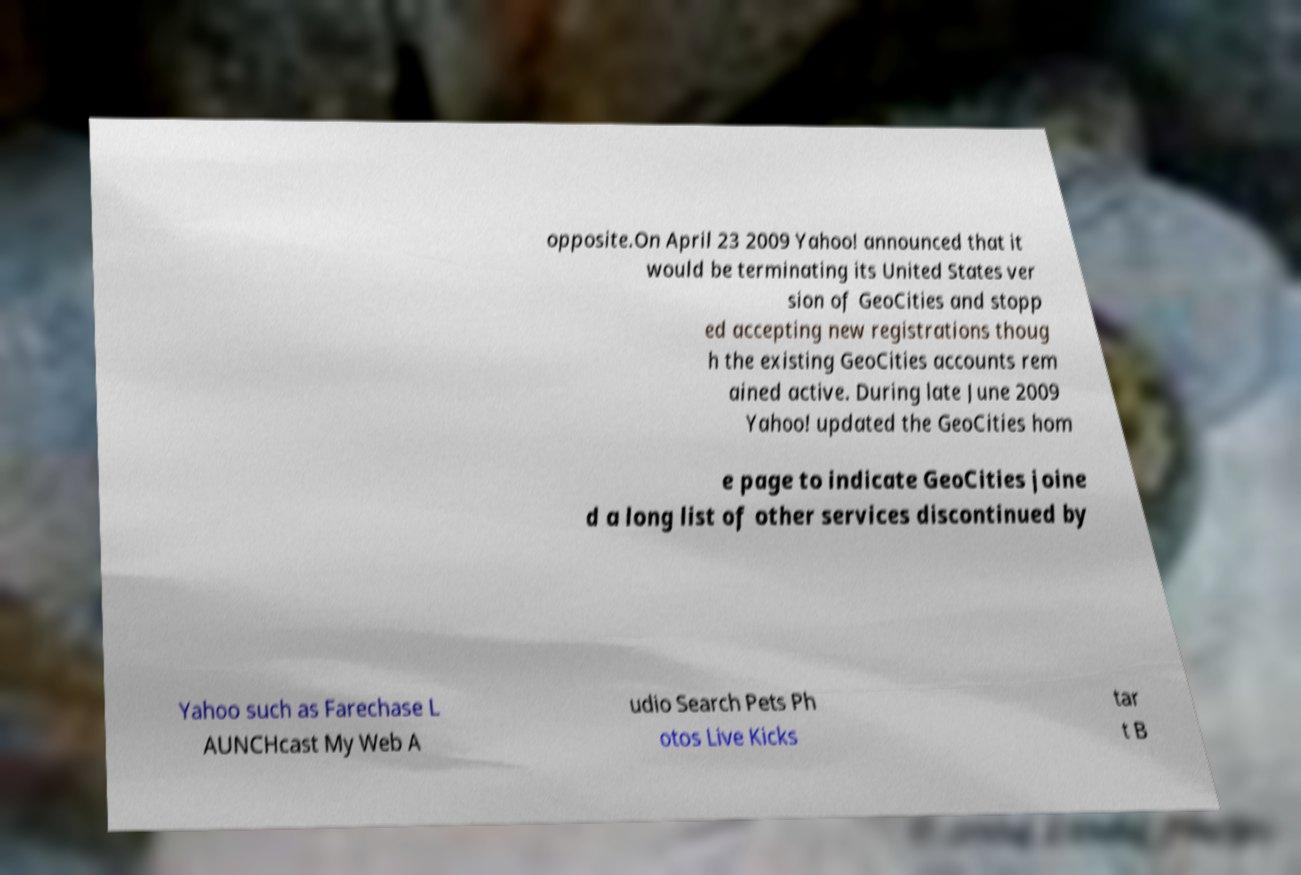What messages or text are displayed in this image? I need them in a readable, typed format. opposite.On April 23 2009 Yahoo! announced that it would be terminating its United States ver sion of GeoCities and stopp ed accepting new registrations thoug h the existing GeoCities accounts rem ained active. During late June 2009 Yahoo! updated the GeoCities hom e page to indicate GeoCities joine d a long list of other services discontinued by Yahoo such as Farechase L AUNCHcast My Web A udio Search Pets Ph otos Live Kicks tar t B 